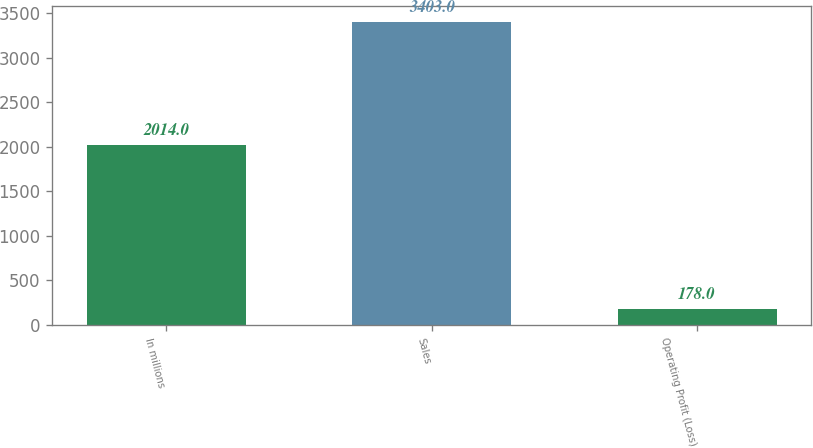Convert chart to OTSL. <chart><loc_0><loc_0><loc_500><loc_500><bar_chart><fcel>In millions<fcel>Sales<fcel>Operating Profit (Loss)<nl><fcel>2014<fcel>3403<fcel>178<nl></chart> 